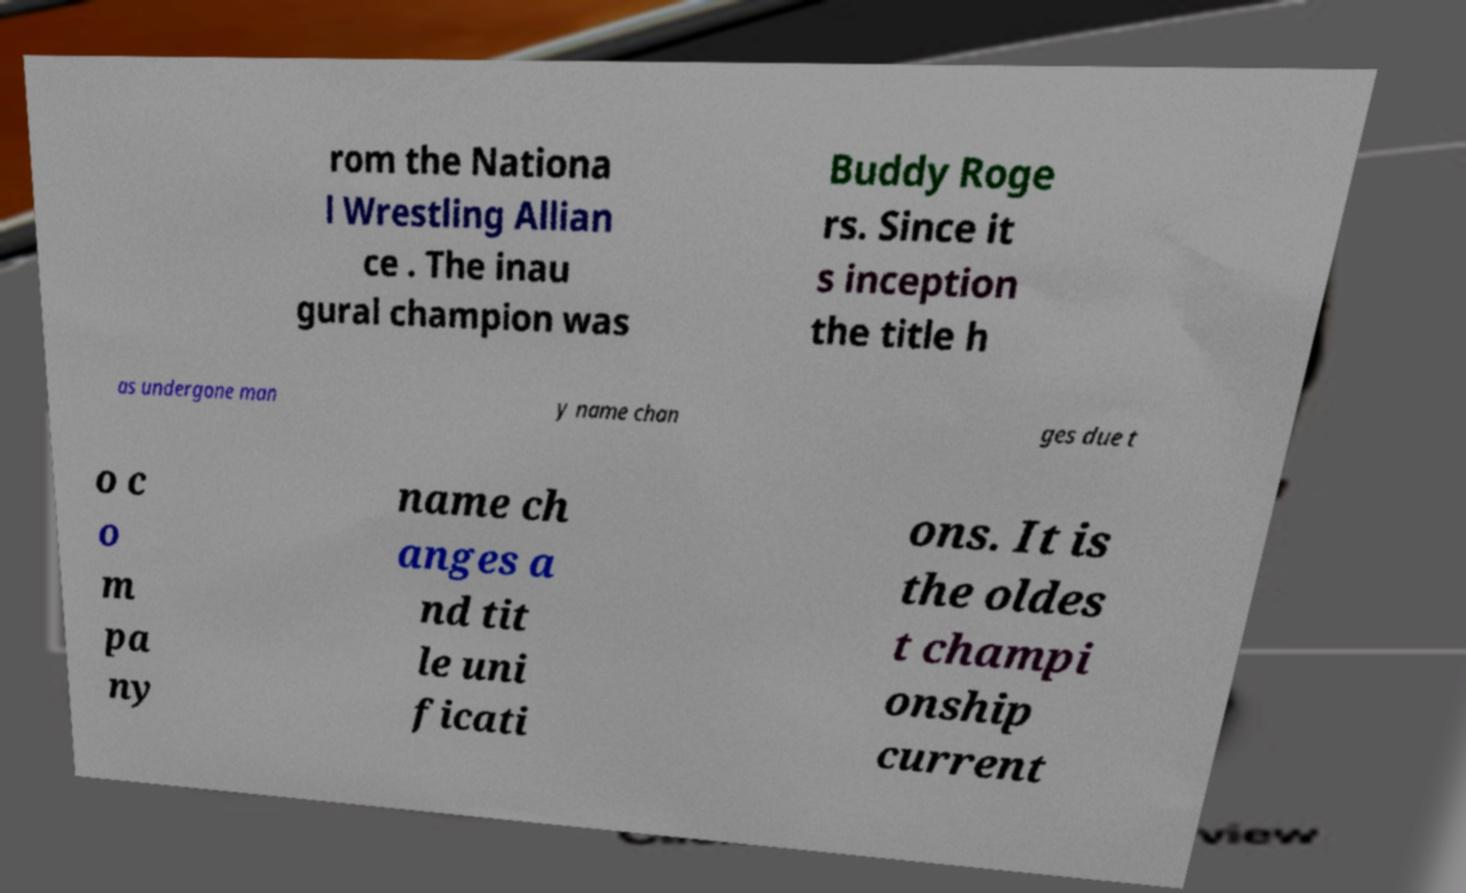There's text embedded in this image that I need extracted. Can you transcribe it verbatim? rom the Nationa l Wrestling Allian ce . The inau gural champion was Buddy Roge rs. Since it s inception the title h as undergone man y name chan ges due t o c o m pa ny name ch anges a nd tit le uni ficati ons. It is the oldes t champi onship current 